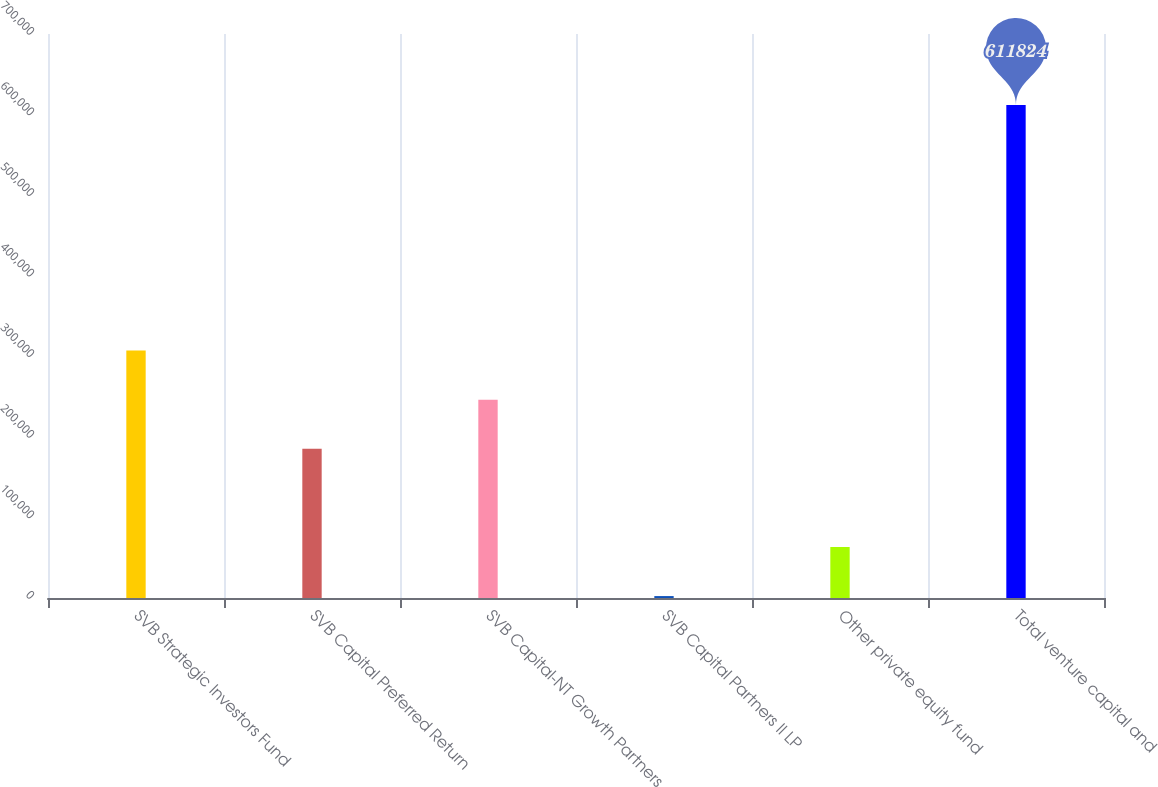Convert chart. <chart><loc_0><loc_0><loc_500><loc_500><bar_chart><fcel>SVB Strategic Investors Fund<fcel>SVB Capital Preferred Return<fcel>SVB Capital-NT Growth Partners<fcel>SVB Capital Partners II LP<fcel>Other private equity fund<fcel>Total venture capital and<nl><fcel>307107<fcel>185220<fcel>246164<fcel>2390<fcel>63333.4<fcel>611824<nl></chart> 